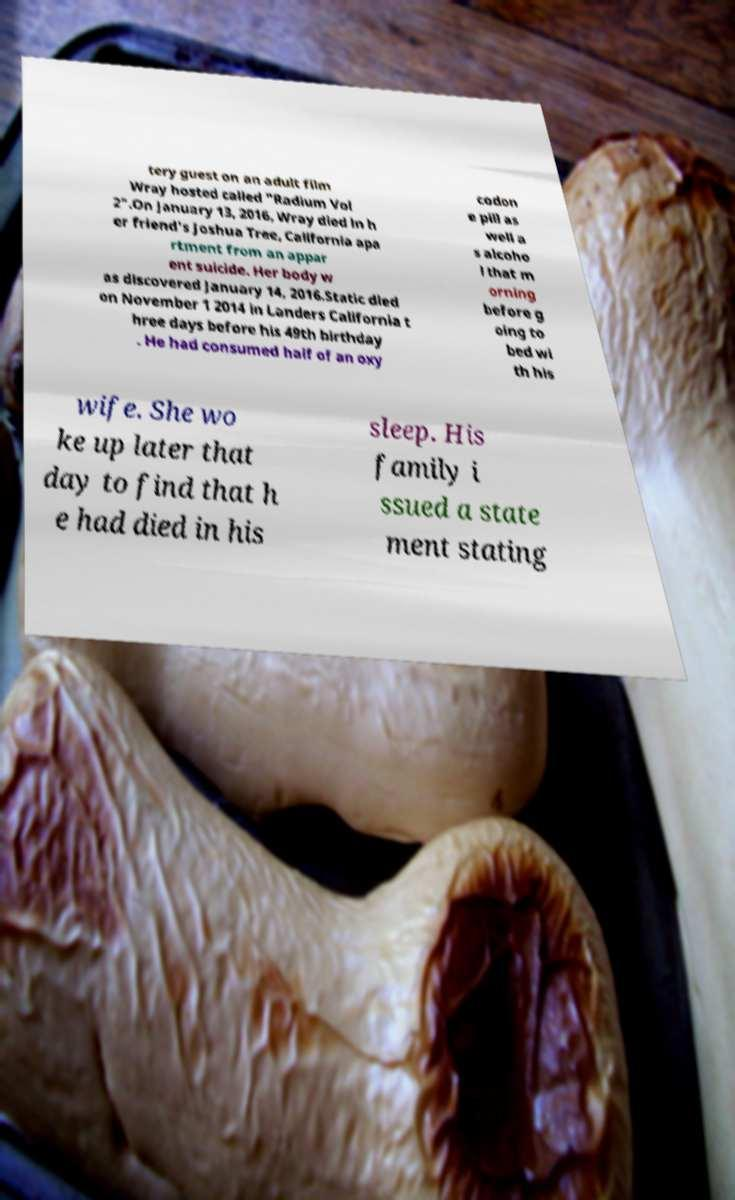Can you accurately transcribe the text from the provided image for me? tery guest on an adult film Wray hosted called "Radium Vol 2".On January 13, 2016, Wray died in h er friend's Joshua Tree, California apa rtment from an appar ent suicide. Her body w as discovered January 14, 2016.Static died on November 1 2014 in Landers California t hree days before his 49th birthday . He had consumed half of an oxy codon e pill as well a s alcoho l that m orning before g oing to bed wi th his wife. She wo ke up later that day to find that h e had died in his sleep. His family i ssued a state ment stating 